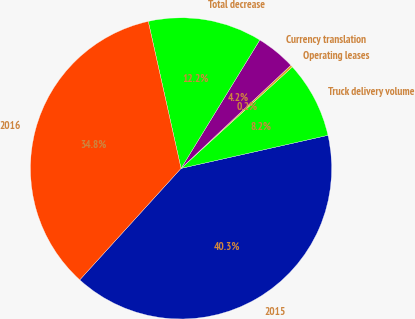<chart> <loc_0><loc_0><loc_500><loc_500><pie_chart><fcel>2015<fcel>Truck delivery volume<fcel>Operating leases<fcel>Currency translation<fcel>Total decrease<fcel>2016<nl><fcel>40.26%<fcel>8.24%<fcel>0.24%<fcel>4.24%<fcel>12.25%<fcel>34.77%<nl></chart> 